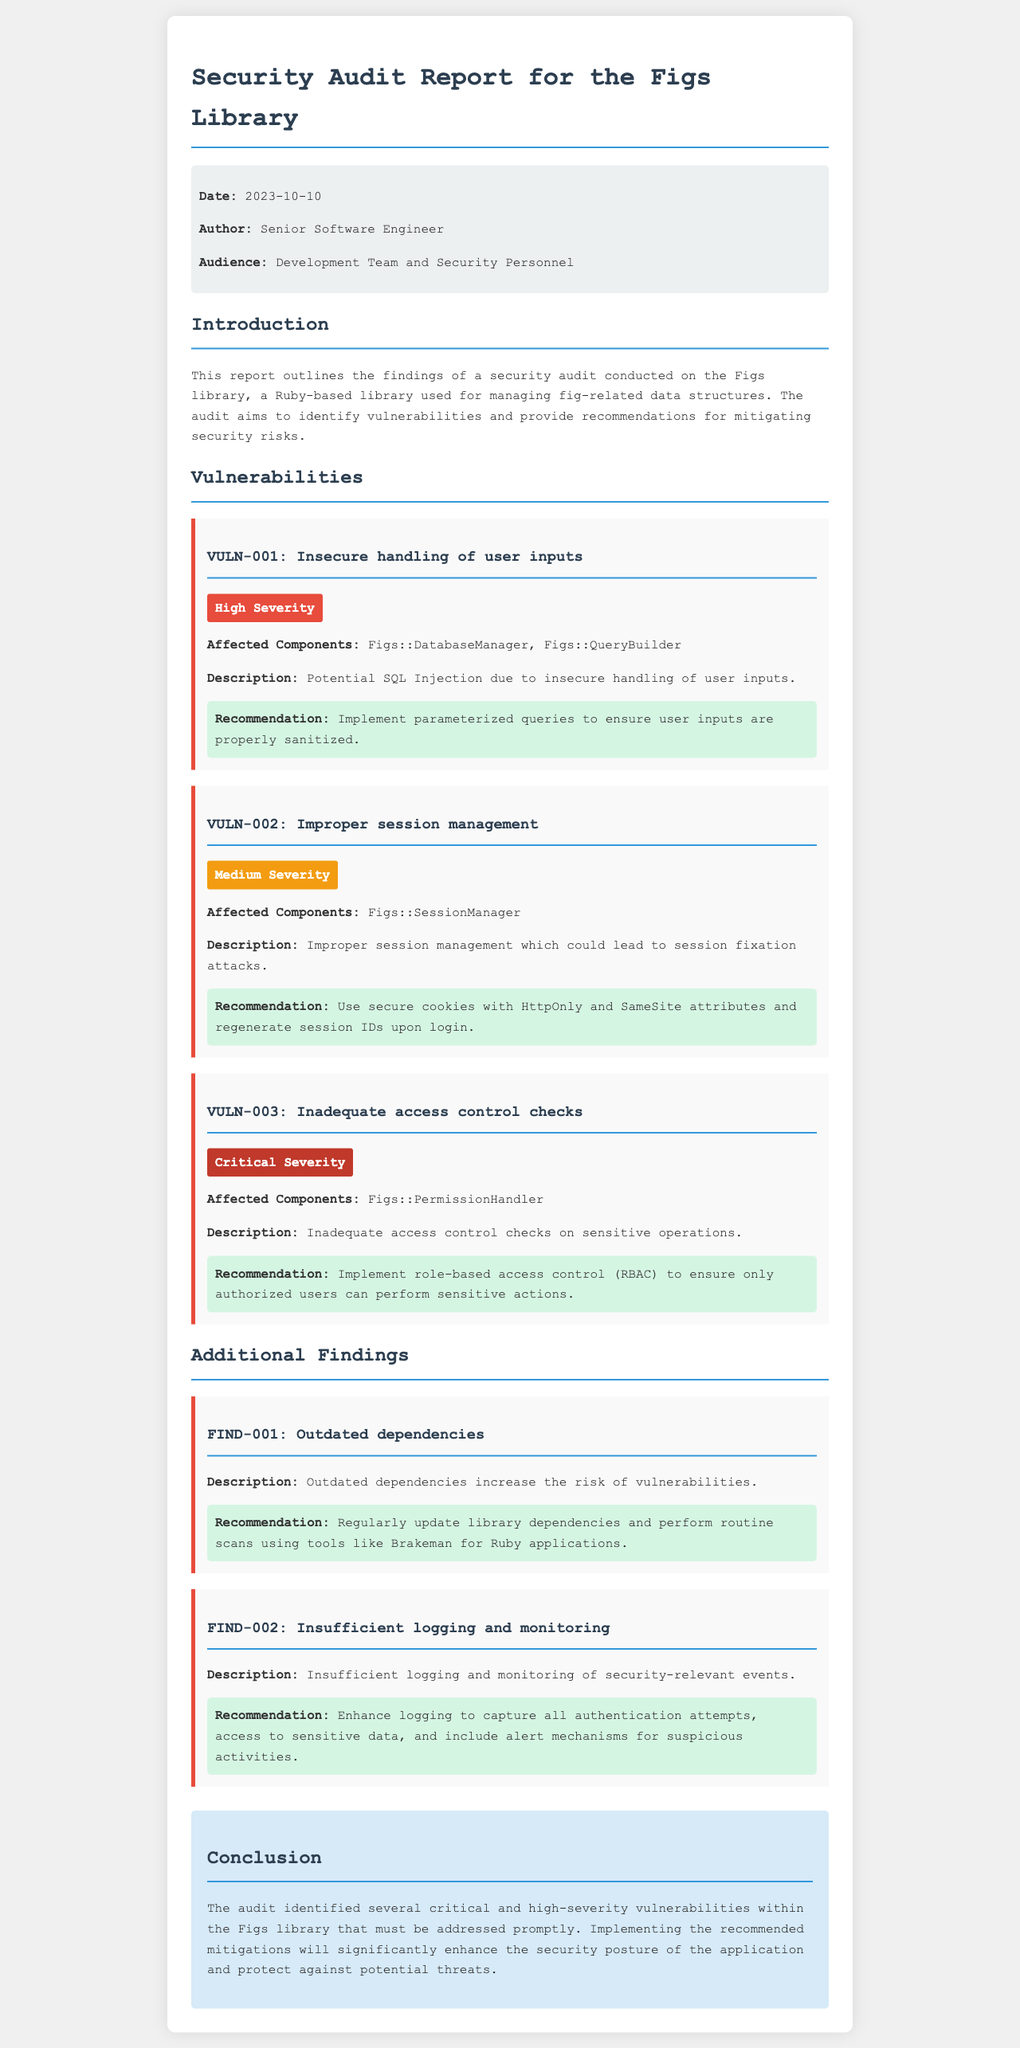What is the date of the security audit report? The date is mentioned in the meta section of the report.
Answer: 2023-10-10 Who is the author of the report? The author is stated in the meta section.
Answer: Senior Software Engineer What is the title of the highest severity vulnerability? The titles of vulnerabilities are listed under the Vulnerabilities section.
Answer: VULN-003: Inadequate access control checks What is the recommendation for VULN-001? The recommendations are provided directly under each vulnerability.
Answer: Implement parameterized queries to ensure user inputs are properly sanitized What is the severity level of VULN-002? The severity level is indicated with a label in the vulnerability section.
Answer: Medium Severity How many additional findings are listed in the report? The number of additional findings can be counted in the Additional Findings section.
Answer: 2 What does the report recommend for outdated dependencies? The recommendation is presented in the findings section.
Answer: Regularly update library dependencies and perform routine scans using tools like Brakeman for Ruby applications What component is affected by VULN-003? The affected components are specified under each vulnerability.
Answer: Figs::PermissionHandler What is the overall conclusion of the report? The conclusion summarizes the findings and suggested actions in the conclusion section.
Answer: The audit identified several critical and high-severity vulnerabilities within the Figs library that must be addressed promptly 